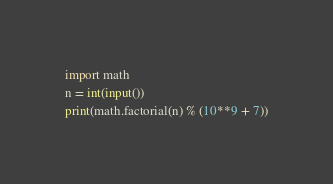Convert code to text. <code><loc_0><loc_0><loc_500><loc_500><_Python_>import math
n = int(input())
print(math.factorial(n) % (10**9 + 7))</code> 